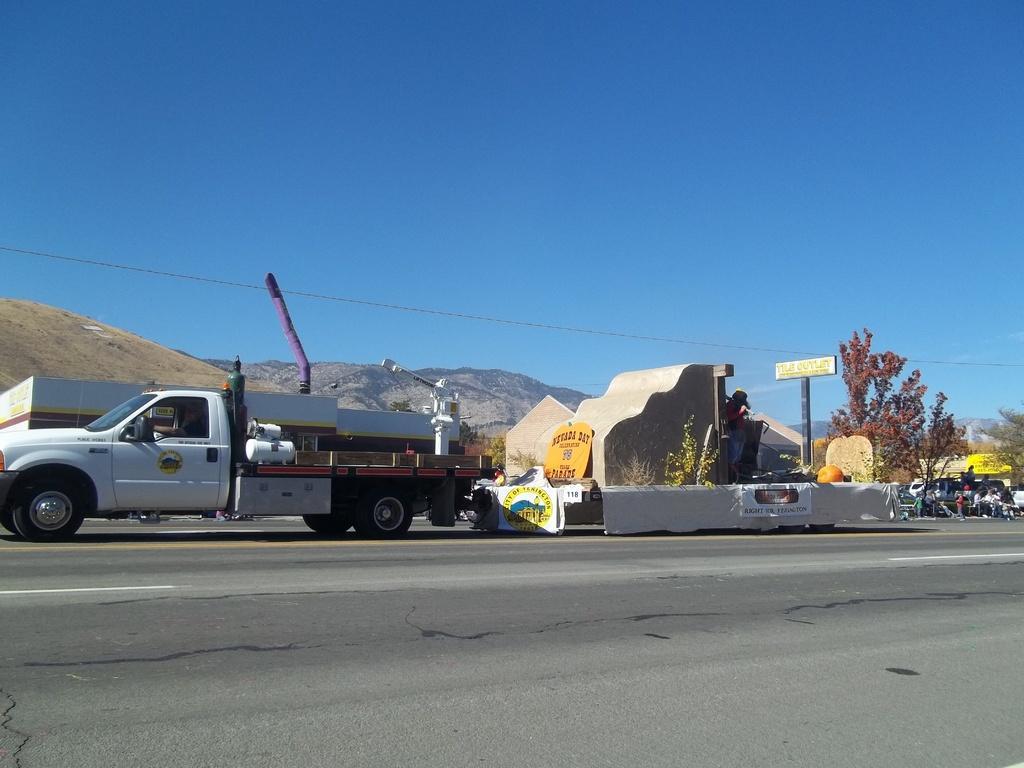In one or two sentences, can you explain what this image depicts? In this image we can see a concrete structure, vehicles, trees, boards, wall and also the hills. We can also see the people on the right. We can see the wire. In the background we can see the sky. At the bottom we can see the road. 